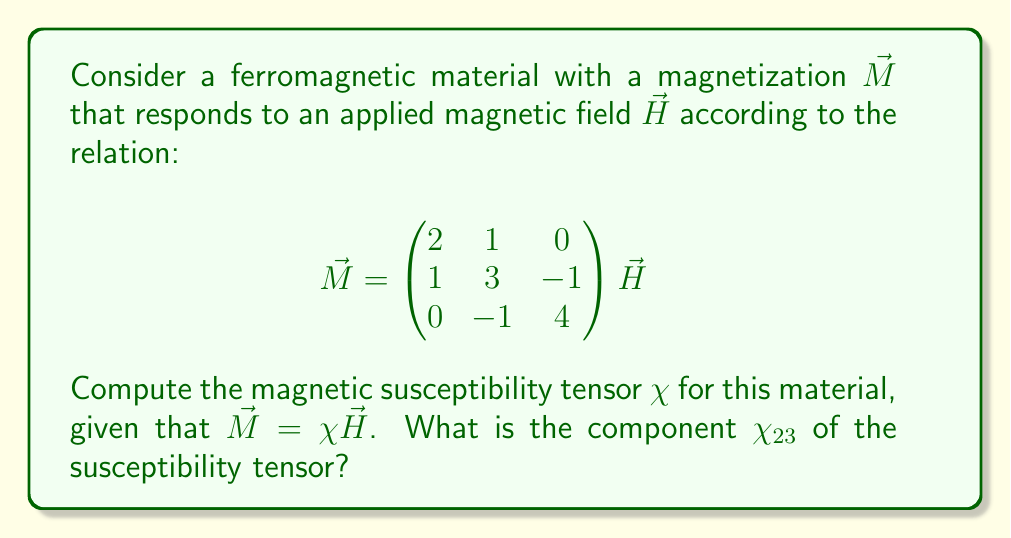Can you answer this question? To solve this problem, we'll follow these steps:

1) Recall that the magnetic susceptibility tensor $\chi$ relates the magnetization $\vec{M}$ to the applied magnetic field $\vec{H}$ through the equation:

   $$\vec{M} = \chi \vec{H}$$

2) From the given relation in the question, we can see that the matrix relating $\vec{M}$ to $\vec{H}$ is:

   $$\chi = \begin{pmatrix}
   2 & 1 & 0 \\
   1 & 3 & -1 \\
   0 & -1 & 4
   \end{pmatrix}$$

3) This matrix is the magnetic susceptibility tensor for the given ferromagnetic material.

4) The component $\chi_{23}$ of the susceptibility tensor is the element in the 2nd row and 3rd column of this matrix.

5) From the matrix, we can see that $\chi_{23} = -1$.

Therefore, the component $\chi_{23}$ of the magnetic susceptibility tensor for this ferromagnetic material is -1.
Answer: $\chi_{23} = -1$ 